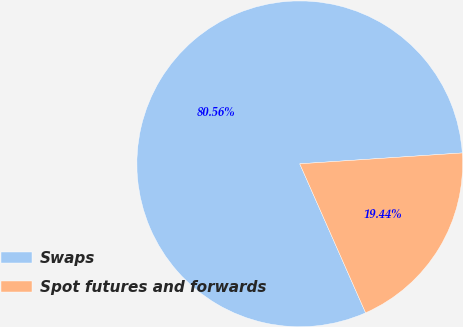<chart> <loc_0><loc_0><loc_500><loc_500><pie_chart><fcel>Swaps<fcel>Spot futures and forwards<nl><fcel>80.56%<fcel>19.44%<nl></chart> 